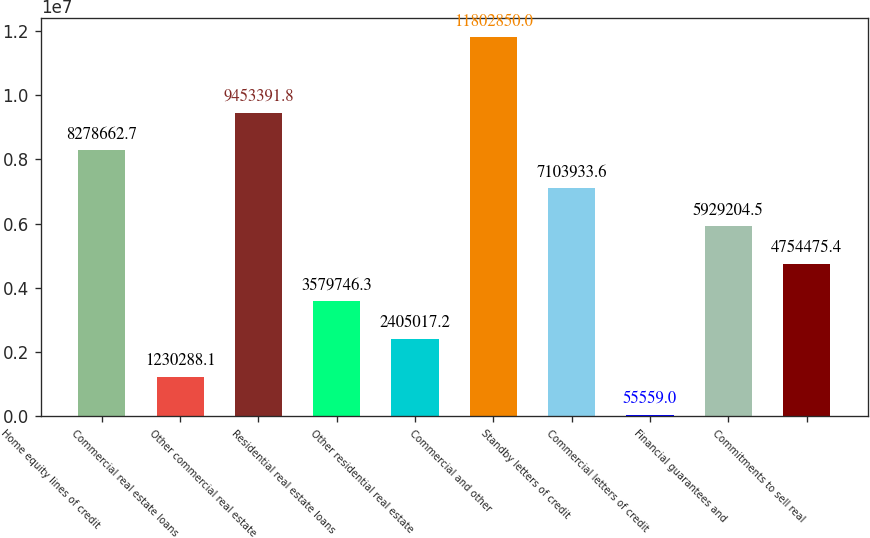<chart> <loc_0><loc_0><loc_500><loc_500><bar_chart><fcel>Home equity lines of credit<fcel>Commercial real estate loans<fcel>Other commercial real estate<fcel>Residential real estate loans<fcel>Other residential real estate<fcel>Commercial and other<fcel>Standby letters of credit<fcel>Commercial letters of credit<fcel>Financial guarantees and<fcel>Commitments to sell real<nl><fcel>8.27866e+06<fcel>1.23029e+06<fcel>9.45339e+06<fcel>3.57975e+06<fcel>2.40502e+06<fcel>1.18028e+07<fcel>7.10393e+06<fcel>55559<fcel>5.9292e+06<fcel>4.75448e+06<nl></chart> 